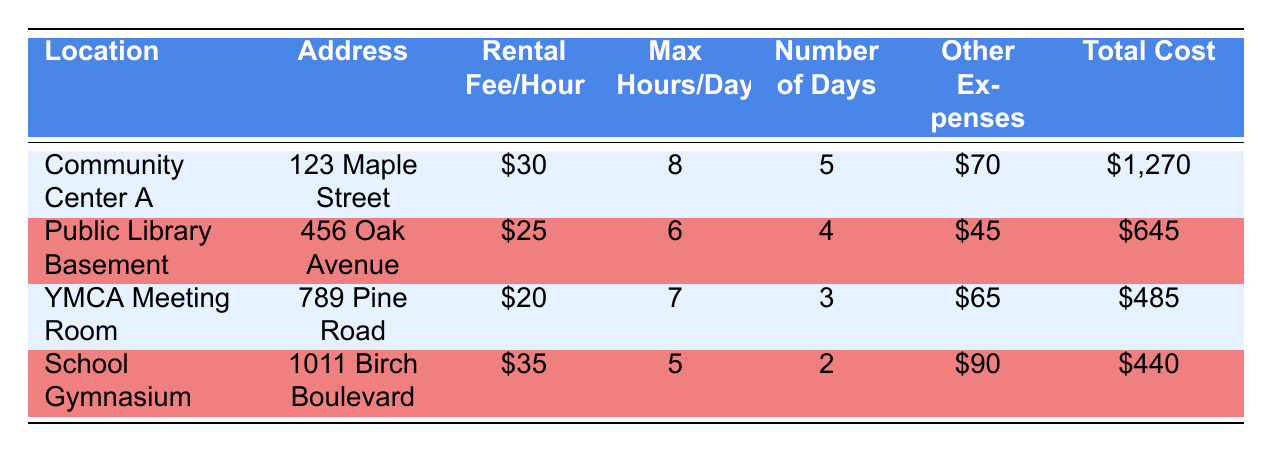What is the rental fee per hour for Community Center A? The table lists the rental fee per hour for each workshop space, where Community Center A is mentioned specifically. According to the data in the table, the rental fee is \$30.
Answer: 30 What is the total cost to rent the YMCA Meeting Room? The total cost for each location is included in the table. For the YMCA Meeting Room, the total cost is directly given as \$485.
Answer: 485 How many days is the School Gymnasium rented? The table indicates the number of days for each rental location. For the School Gymnasium, it shows that it is rented for 2 days.
Answer: 2 Which location has the highest total cost? To determine which location has the highest total cost, we look at the total costs listed: Community Center A is \$1,270, Public Library Basement is \$645, YMCA Meeting Room is \$485, and School Gymnasium is \$440. The highest total cost is at Community Center A.
Answer: Community Center A What are the other expenses of renting the Public Library Basement? The table provides a breakdown of other expenses for each location. For the Public Library Basement, the cleaning fee is \$30 and the utility fee is \$15. So, the total other expenses amount to \$45.
Answer: 45 What is the average rental fee per hour across all locations? To find the average rental fee per hour, we first add up the rental fees for all locations: 30 + 25 + 20 + 35 = 110. There are 4 locations, so we divide the total by 4: 110/4 = 27.5.
Answer: 27.5 Is the rental fee for the YMCA Meeting Room less than \$25? The table shows that the rental fee for the YMCA Meeting Room is \$20. Since \$20 is less than \$25, the statement is true.
Answer: Yes If I were to rent each location for the maximum number of days mentioned, how much would that be in total? We need to calculate the total for each location by multiplying the rental fee per hour by the maximum hours per day, then by the number of days. Community Center A: 30 * 8 * 5 = 1200, Public Library Basement: 25 * 6 * 4 = 600, YMCA Meeting Room: 20 * 7 * 3 = 420, School Gymnasium: 35 * 5 * 2 = 350. Adding these gives: 1200 + 600 + 420 + 350 = 2570. Thus, the total cost would be \$2570.
Answer: 2570 Which location offers the most hours available for rent per day? The maximum hours per day per location are as follows: Community Center A has 8 hours, Public Library Basement has 6 hours, YMCA Meeting Room has 7 hours, and School Gymnasium has 5 hours. Therefore, Community Center A offers the most hours available per day.
Answer: Community Center A 